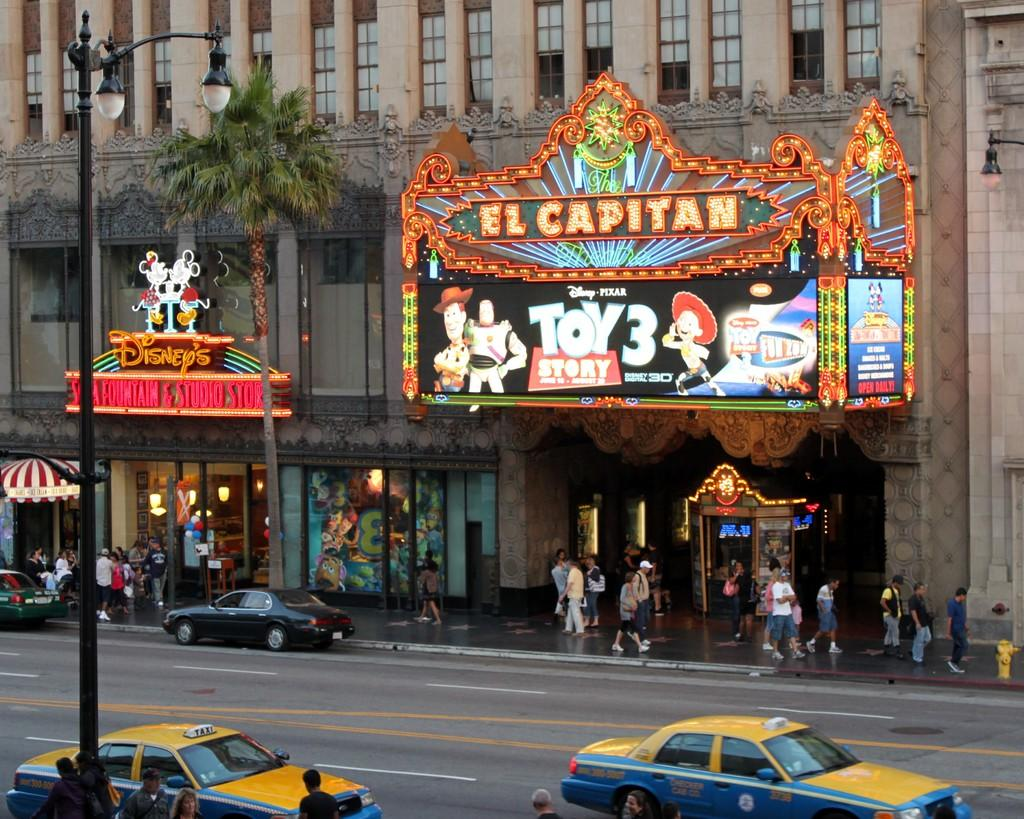<image>
Relay a brief, clear account of the picture shown. A group of people are walking under a sign that says Toy Story 3. 